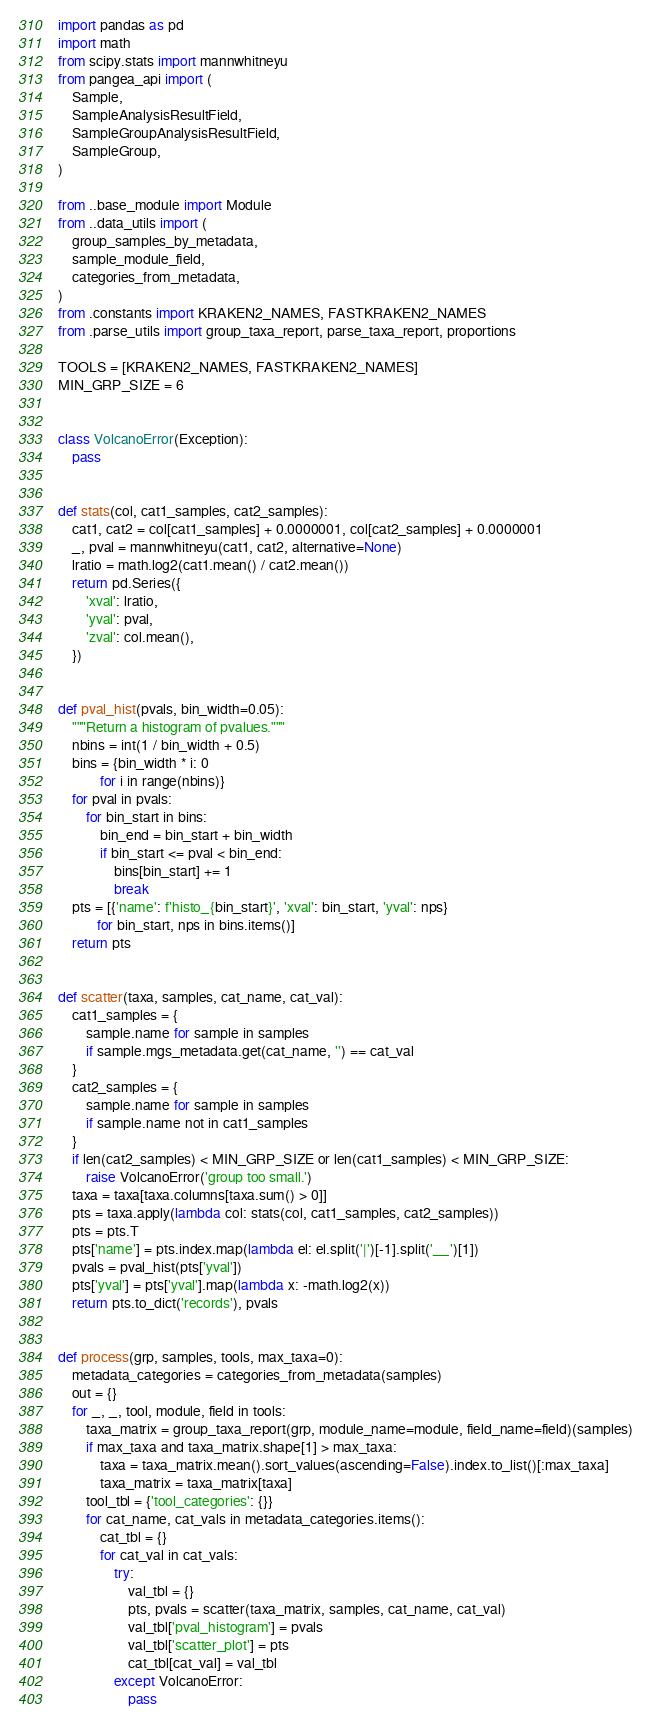<code> <loc_0><loc_0><loc_500><loc_500><_Python_>
import pandas as pd
import math
from scipy.stats import mannwhitneyu
from pangea_api import (
    Sample,
    SampleAnalysisResultField,
    SampleGroupAnalysisResultField,
    SampleGroup,
)

from ..base_module import Module
from ..data_utils import (
    group_samples_by_metadata,
    sample_module_field,
    categories_from_metadata,
)
from .constants import KRAKEN2_NAMES, FASTKRAKEN2_NAMES
from .parse_utils import group_taxa_report, parse_taxa_report, proportions

TOOLS = [KRAKEN2_NAMES, FASTKRAKEN2_NAMES]
MIN_GRP_SIZE = 6


class VolcanoError(Exception):
    pass


def stats(col, cat1_samples, cat2_samples):
    cat1, cat2 = col[cat1_samples] + 0.0000001, col[cat2_samples] + 0.0000001
    _, pval = mannwhitneyu(cat1, cat2, alternative=None)
    lratio = math.log2(cat1.mean() / cat2.mean())
    return pd.Series({
        'xval': lratio,
        'yval': pval,
        'zval': col.mean(),
    })


def pval_hist(pvals, bin_width=0.05):
    """Return a histogram of pvalues."""
    nbins = int(1 / bin_width + 0.5)
    bins = {bin_width * i: 0
            for i in range(nbins)}
    for pval in pvals:
        for bin_start in bins:
            bin_end = bin_start + bin_width
            if bin_start <= pval < bin_end:
                bins[bin_start] += 1
                break
    pts = [{'name': f'histo_{bin_start}', 'xval': bin_start, 'yval': nps}
           for bin_start, nps in bins.items()]
    return pts


def scatter(taxa, samples, cat_name, cat_val):
    cat1_samples = {
        sample.name for sample in samples
        if sample.mgs_metadata.get(cat_name, '') == cat_val
    }
    cat2_samples = {
        sample.name for sample in samples
        if sample.name not in cat1_samples
    }
    if len(cat2_samples) < MIN_GRP_SIZE or len(cat1_samples) < MIN_GRP_SIZE:
        raise VolcanoError('group too small.')
    taxa = taxa[taxa.columns[taxa.sum() > 0]]
    pts = taxa.apply(lambda col: stats(col, cat1_samples, cat2_samples))
    pts = pts.T
    pts['name'] = pts.index.map(lambda el: el.split('|')[-1].split('__')[1])
    pvals = pval_hist(pts['yval'])
    pts['yval'] = pts['yval'].map(lambda x: -math.log2(x))
    return pts.to_dict('records'), pvals


def process(grp, samples, tools, max_taxa=0):
    metadata_categories = categories_from_metadata(samples)
    out = {}
    for _, _, tool, module, field in tools:
        taxa_matrix = group_taxa_report(grp, module_name=module, field_name=field)(samples)
        if max_taxa and taxa_matrix.shape[1] > max_taxa:
            taxa = taxa_matrix.mean().sort_values(ascending=False).index.to_list()[:max_taxa]
            taxa_matrix = taxa_matrix[taxa]
        tool_tbl = {'tool_categories': {}}
        for cat_name, cat_vals in metadata_categories.items():
            cat_tbl = {}
            for cat_val in cat_vals:
                try:
                    val_tbl = {}
                    pts, pvals = scatter(taxa_matrix, samples, cat_name, cat_val)
                    val_tbl['pval_histogram'] = pvals
                    val_tbl['scatter_plot'] = pts
                    cat_tbl[cat_val] = val_tbl
                except VolcanoError:
                    pass</code> 